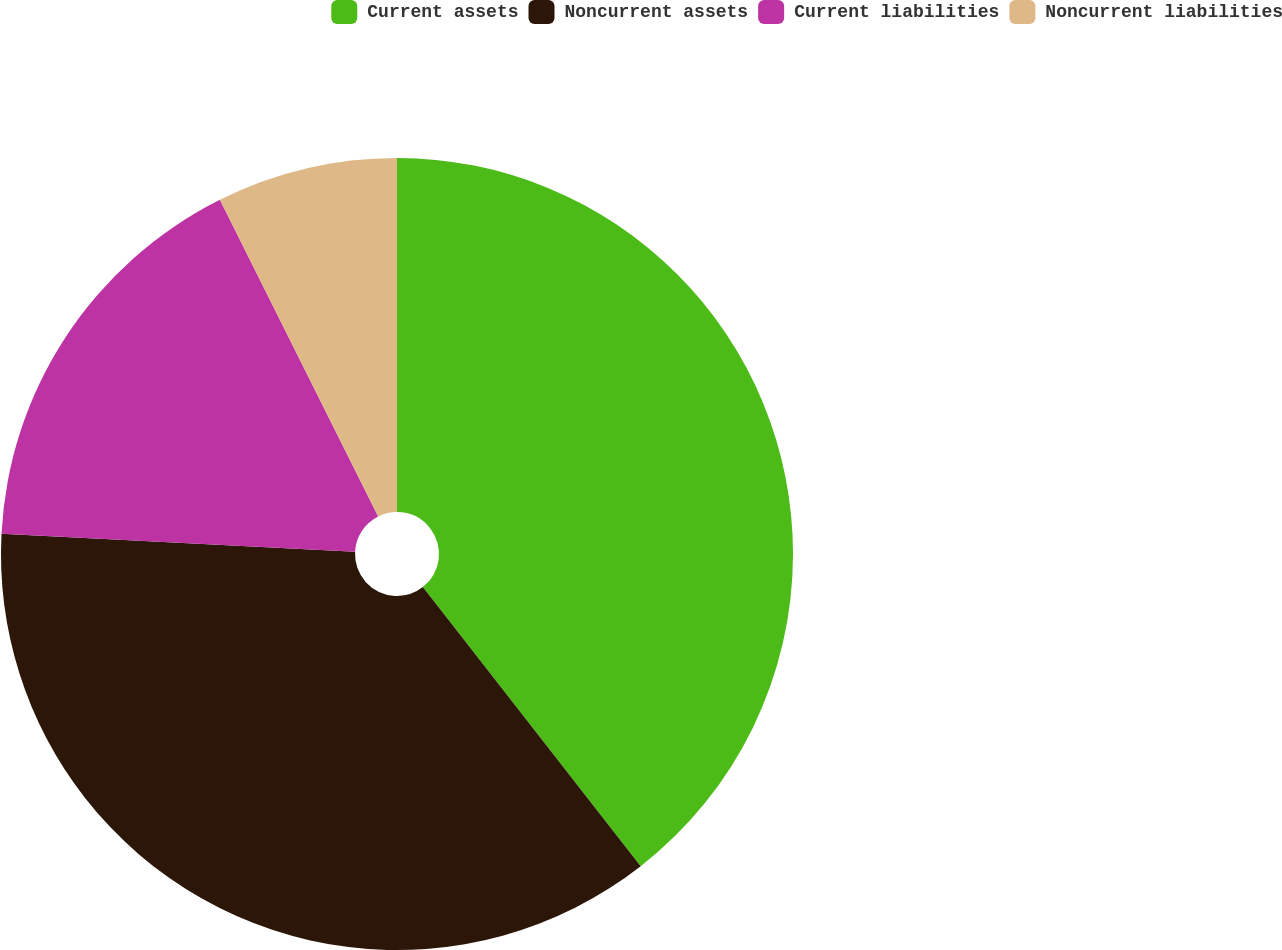<chart> <loc_0><loc_0><loc_500><loc_500><pie_chart><fcel>Current assets<fcel>Noncurrent assets<fcel>Current liabilities<fcel>Noncurrent liabilities<nl><fcel>39.45%<fcel>36.36%<fcel>16.81%<fcel>7.38%<nl></chart> 